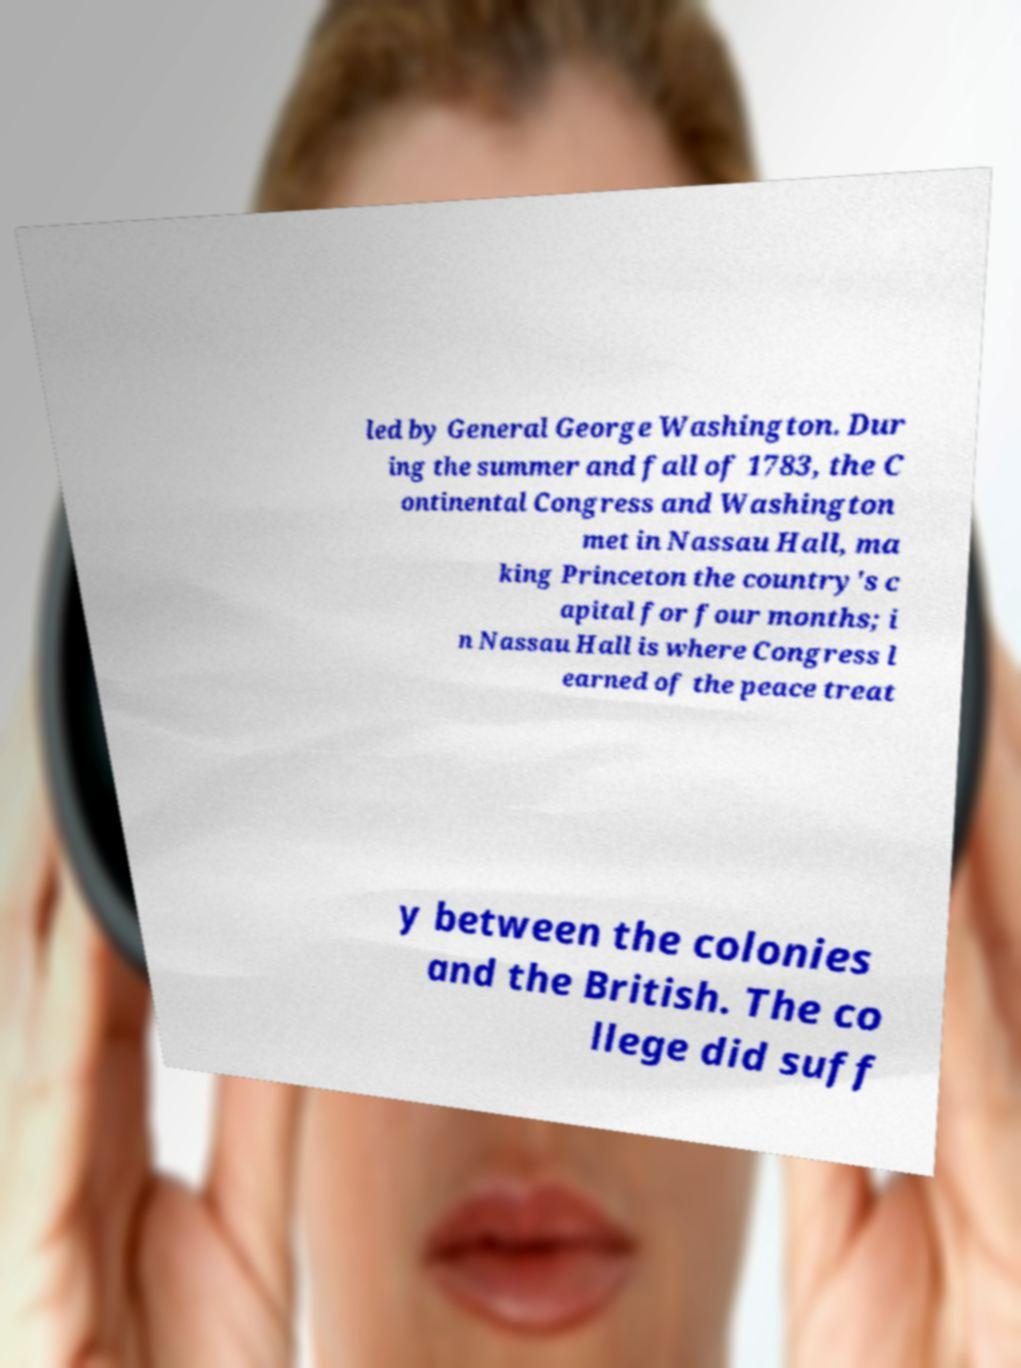Could you extract and type out the text from this image? led by General George Washington. Dur ing the summer and fall of 1783, the C ontinental Congress and Washington met in Nassau Hall, ma king Princeton the country's c apital for four months; i n Nassau Hall is where Congress l earned of the peace treat y between the colonies and the British. The co llege did suff 